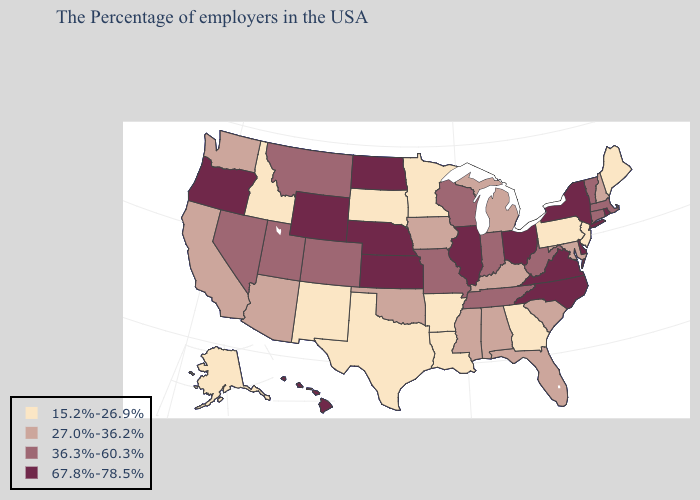Among the states that border New Hampshire , does Maine have the highest value?
Write a very short answer. No. What is the lowest value in the South?
Be succinct. 15.2%-26.9%. Which states have the lowest value in the Northeast?
Short answer required. Maine, New Jersey, Pennsylvania. Which states hav the highest value in the Northeast?
Give a very brief answer. Rhode Island, New York. Among the states that border Utah , which have the highest value?
Write a very short answer. Wyoming. What is the highest value in the West ?
Short answer required. 67.8%-78.5%. What is the value of Utah?
Short answer required. 36.3%-60.3%. Among the states that border Vermont , does New Hampshire have the highest value?
Concise answer only. No. What is the lowest value in states that border Virginia?
Concise answer only. 27.0%-36.2%. What is the lowest value in the USA?
Be succinct. 15.2%-26.9%. Name the states that have a value in the range 67.8%-78.5%?
Be succinct. Rhode Island, New York, Delaware, Virginia, North Carolina, Ohio, Illinois, Kansas, Nebraska, North Dakota, Wyoming, Oregon, Hawaii. Among the states that border West Virginia , does Pennsylvania have the lowest value?
Give a very brief answer. Yes. Which states hav the highest value in the MidWest?
Keep it brief. Ohio, Illinois, Kansas, Nebraska, North Dakota. Among the states that border North Dakota , which have the highest value?
Write a very short answer. Montana. Which states have the lowest value in the USA?
Be succinct. Maine, New Jersey, Pennsylvania, Georgia, Louisiana, Arkansas, Minnesota, Texas, South Dakota, New Mexico, Idaho, Alaska. 